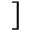Convert formula to latex. <formula><loc_0><loc_0><loc_500><loc_500>]</formula> 